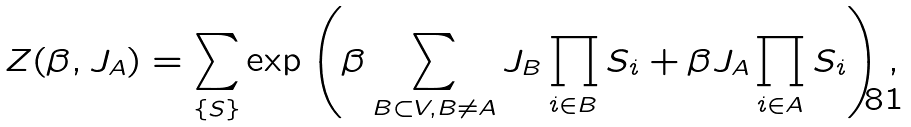Convert formula to latex. <formula><loc_0><loc_0><loc_500><loc_500>Z ( \beta , J _ { A } ) = \sum _ { \{ S \} } \exp \left ( \beta \sum _ { B \subset V , B \neq A } J _ { B } \prod _ { i \in B } S _ { i } + \beta J _ { A } \prod _ { i \in A } S _ { i } \right ) ,</formula> 